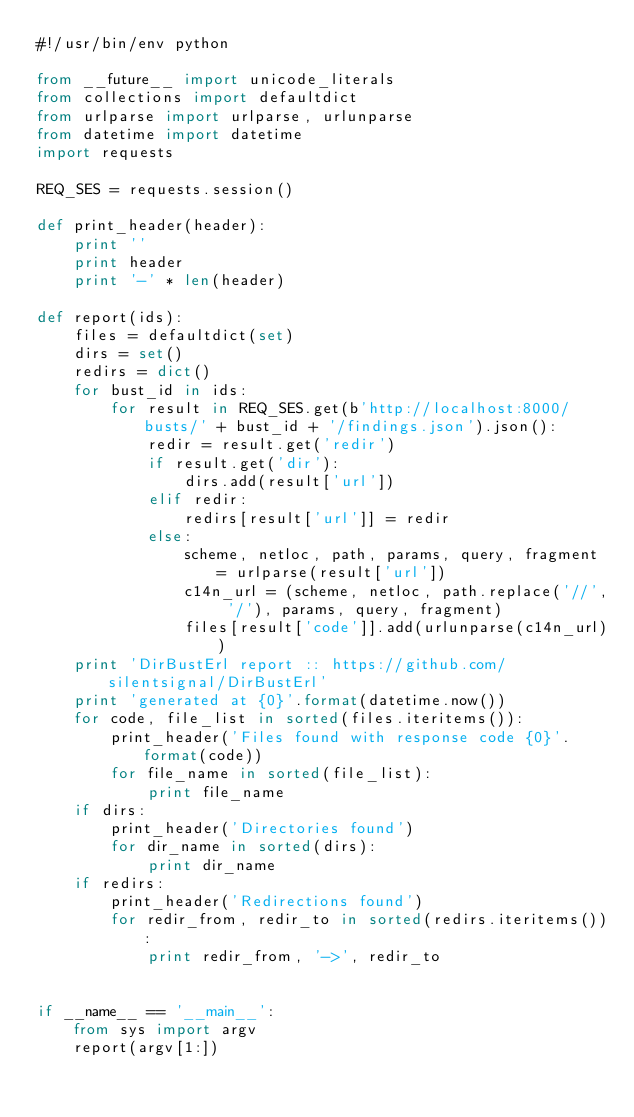<code> <loc_0><loc_0><loc_500><loc_500><_Python_>#!/usr/bin/env python

from __future__ import unicode_literals
from collections import defaultdict
from urlparse import urlparse, urlunparse
from datetime import datetime
import requests

REQ_SES = requests.session()

def print_header(header):
    print ''
    print header
    print '-' * len(header)

def report(ids):
    files = defaultdict(set)
    dirs = set()
    redirs = dict()
    for bust_id in ids:
        for result in REQ_SES.get(b'http://localhost:8000/busts/' + bust_id + '/findings.json').json():
            redir = result.get('redir')
            if result.get('dir'):
                dirs.add(result['url'])
            elif redir:
                redirs[result['url']] = redir
            else:
                scheme, netloc, path, params, query, fragment = urlparse(result['url'])
                c14n_url = (scheme, netloc, path.replace('//', '/'), params, query, fragment)
                files[result['code']].add(urlunparse(c14n_url))
    print 'DirBustErl report :: https://github.com/silentsignal/DirBustErl'
    print 'generated at {0}'.format(datetime.now())
    for code, file_list in sorted(files.iteritems()):
        print_header('Files found with response code {0}'.format(code))
        for file_name in sorted(file_list):
            print file_name
    if dirs:
        print_header('Directories found')
        for dir_name in sorted(dirs):
            print dir_name
    if redirs:
        print_header('Redirections found')
        for redir_from, redir_to in sorted(redirs.iteritems()):
            print redir_from, '->', redir_to


if __name__ == '__main__':
    from sys import argv
    report(argv[1:])
</code> 